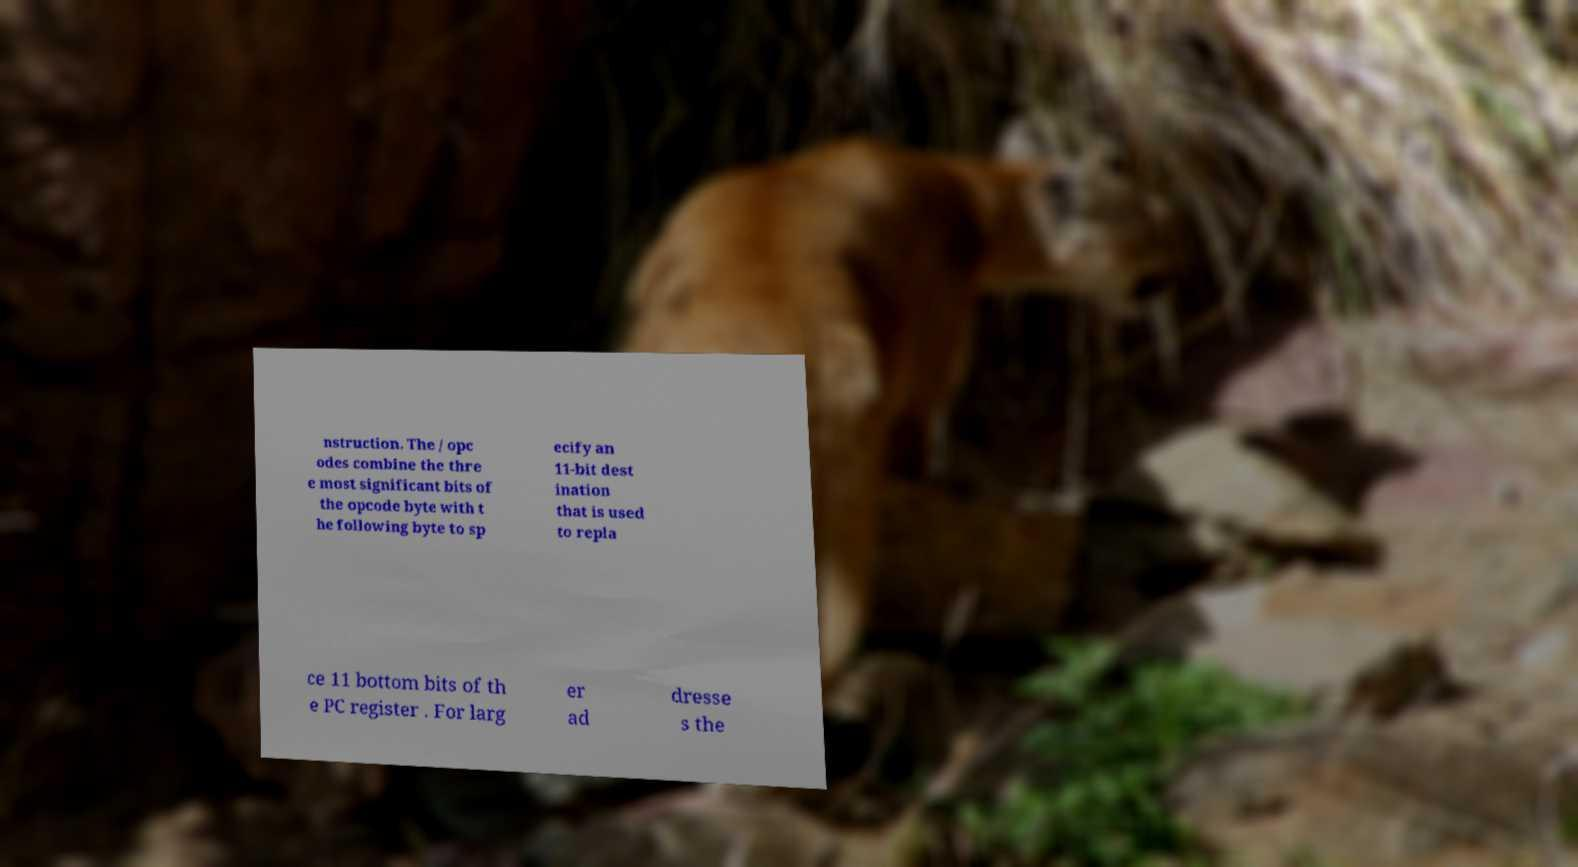Could you assist in decoding the text presented in this image and type it out clearly? nstruction. The / opc odes combine the thre e most significant bits of the opcode byte with t he following byte to sp ecify an 11-bit dest ination that is used to repla ce 11 bottom bits of th e PC register . For larg er ad dresse s the 